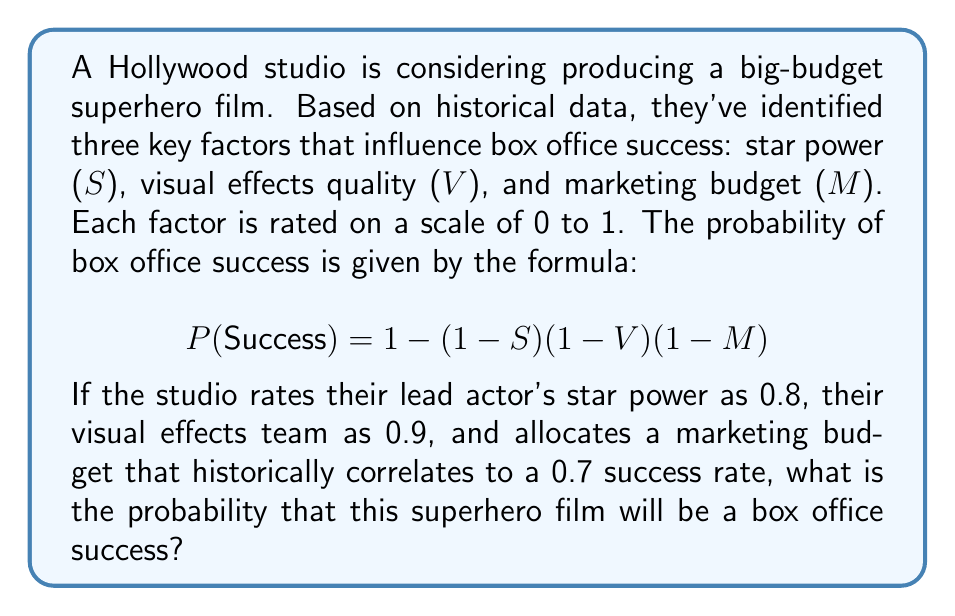Could you help me with this problem? Let's approach this step-by-step:

1) We are given the formula for the probability of success:
   $$P(\text{Success}) = 1 - (1-S)(1-V)(1-M)$$

2) We are also given the values for each factor:
   $S = 0.8$ (Star power)
   $V = 0.9$ (Visual effects quality)
   $M = 0.7$ (Marketing budget effectiveness)

3) Let's substitute these values into our formula:
   $$P(\text{Success}) = 1 - (1-0.8)(1-0.9)(1-0.7)$$

4) Now, let's calculate each term inside the parentheses:
   $(1-0.8) = 0.2$
   $(1-0.9) = 0.1$
   $(1-0.7) = 0.3$

5) Our equation now looks like this:
   $$P(\text{Success}) = 1 - (0.2)(0.1)(0.3)$$

6) Multiply the terms inside the parentheses:
   $$P(\text{Success}) = 1 - 0.006$$

7) Finally, subtract:
   $$P(\text{Success}) = 0.994$$

Therefore, the probability of box office success for this superhero film is 0.994 or 99.4%.
Answer: 0.994 